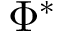Convert formula to latex. <formula><loc_0><loc_0><loc_500><loc_500>\Phi ^ { \ast }</formula> 